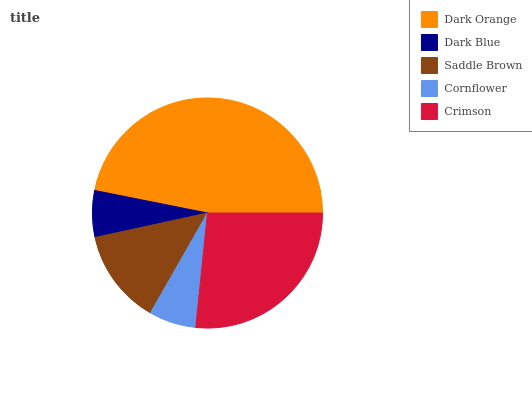Is Dark Blue the minimum?
Answer yes or no. Yes. Is Dark Orange the maximum?
Answer yes or no. Yes. Is Saddle Brown the minimum?
Answer yes or no. No. Is Saddle Brown the maximum?
Answer yes or no. No. Is Saddle Brown greater than Dark Blue?
Answer yes or no. Yes. Is Dark Blue less than Saddle Brown?
Answer yes or no. Yes. Is Dark Blue greater than Saddle Brown?
Answer yes or no. No. Is Saddle Brown less than Dark Blue?
Answer yes or no. No. Is Saddle Brown the high median?
Answer yes or no. Yes. Is Saddle Brown the low median?
Answer yes or no. Yes. Is Cornflower the high median?
Answer yes or no. No. Is Dark Blue the low median?
Answer yes or no. No. 